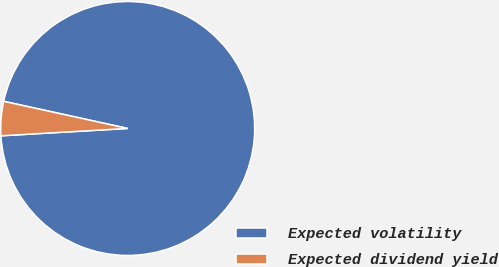<chart> <loc_0><loc_0><loc_500><loc_500><pie_chart><fcel>Expected volatility<fcel>Expected dividend yield<nl><fcel>95.65%<fcel>4.35%<nl></chart> 